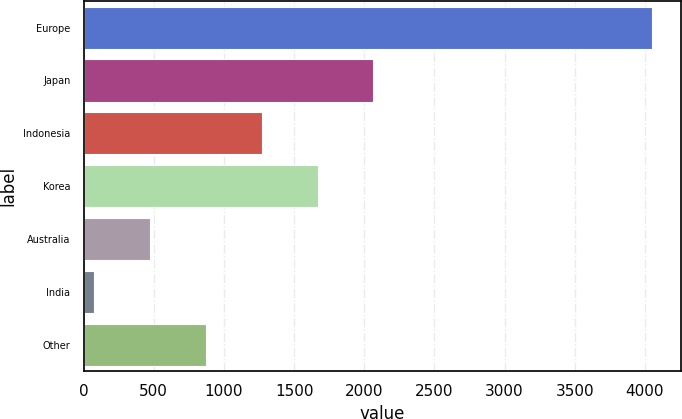<chart> <loc_0><loc_0><loc_500><loc_500><bar_chart><fcel>Europe<fcel>Japan<fcel>Indonesia<fcel>Korea<fcel>Australia<fcel>India<fcel>Other<nl><fcel>4053<fcel>2064.5<fcel>1269.1<fcel>1666.8<fcel>473.7<fcel>76<fcel>871.4<nl></chart> 